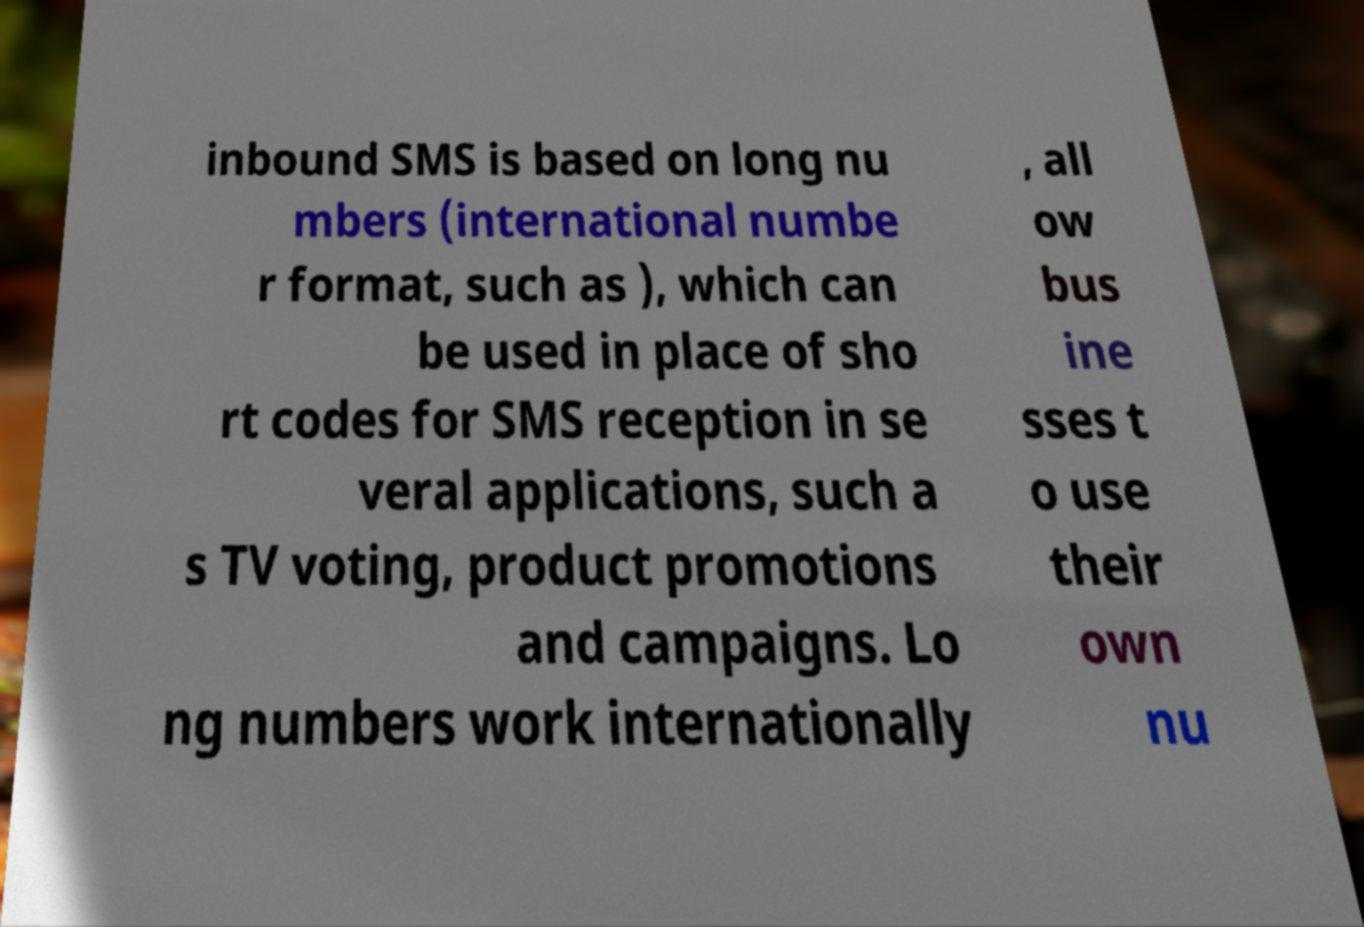Could you extract and type out the text from this image? inbound SMS is based on long nu mbers (international numbe r format, such as ), which can be used in place of sho rt codes for SMS reception in se veral applications, such a s TV voting, product promotions and campaigns. Lo ng numbers work internationally , all ow bus ine sses t o use their own nu 